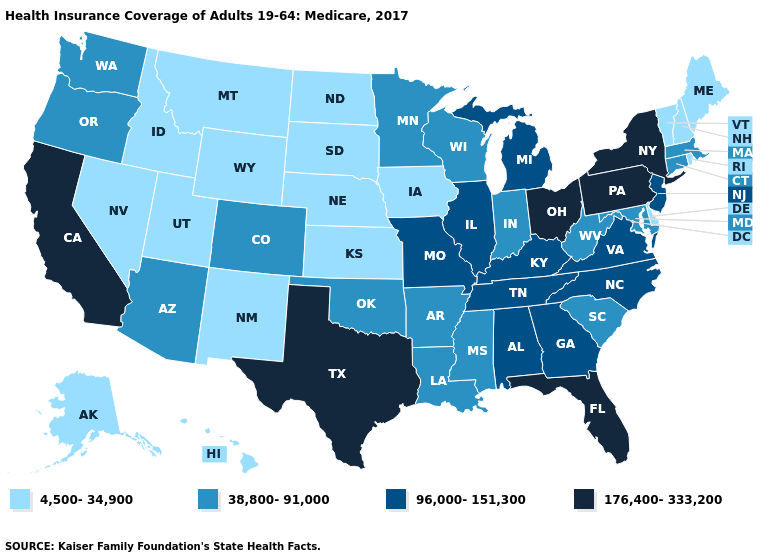Which states have the lowest value in the MidWest?
Short answer required. Iowa, Kansas, Nebraska, North Dakota, South Dakota. Does New Jersey have the lowest value in the USA?
Concise answer only. No. Among the states that border Missouri , does Arkansas have the highest value?
Be succinct. No. What is the value of Utah?
Quick response, please. 4,500-34,900. Name the states that have a value in the range 4,500-34,900?
Short answer required. Alaska, Delaware, Hawaii, Idaho, Iowa, Kansas, Maine, Montana, Nebraska, Nevada, New Hampshire, New Mexico, North Dakota, Rhode Island, South Dakota, Utah, Vermont, Wyoming. What is the lowest value in the USA?
Keep it brief. 4,500-34,900. Which states hav the highest value in the MidWest?
Short answer required. Ohio. Does Delaware have the lowest value in the South?
Write a very short answer. Yes. Name the states that have a value in the range 176,400-333,200?
Keep it brief. California, Florida, New York, Ohio, Pennsylvania, Texas. Name the states that have a value in the range 38,800-91,000?
Keep it brief. Arizona, Arkansas, Colorado, Connecticut, Indiana, Louisiana, Maryland, Massachusetts, Minnesota, Mississippi, Oklahoma, Oregon, South Carolina, Washington, West Virginia, Wisconsin. What is the lowest value in the USA?
Answer briefly. 4,500-34,900. Name the states that have a value in the range 176,400-333,200?
Keep it brief. California, Florida, New York, Ohio, Pennsylvania, Texas. Among the states that border Illinois , does Indiana have the highest value?
Give a very brief answer. No. Among the states that border Pennsylvania , does Delaware have the highest value?
Answer briefly. No. Name the states that have a value in the range 176,400-333,200?
Be succinct. California, Florida, New York, Ohio, Pennsylvania, Texas. 